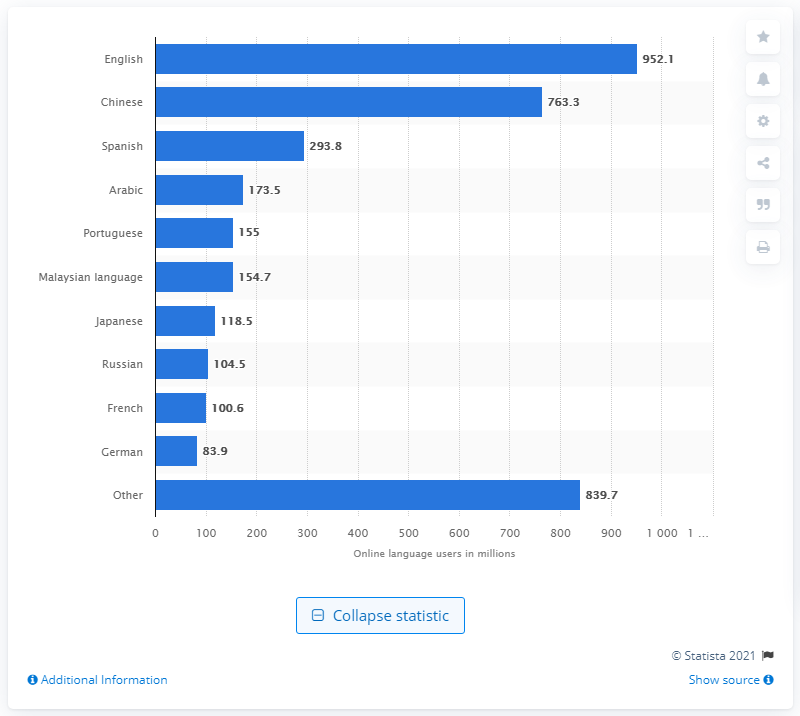Draw attention to some important aspects in this diagram. In March 2017, the second most popular language on the internet was Chinese. As of March 2017, English was the most popular language online. 